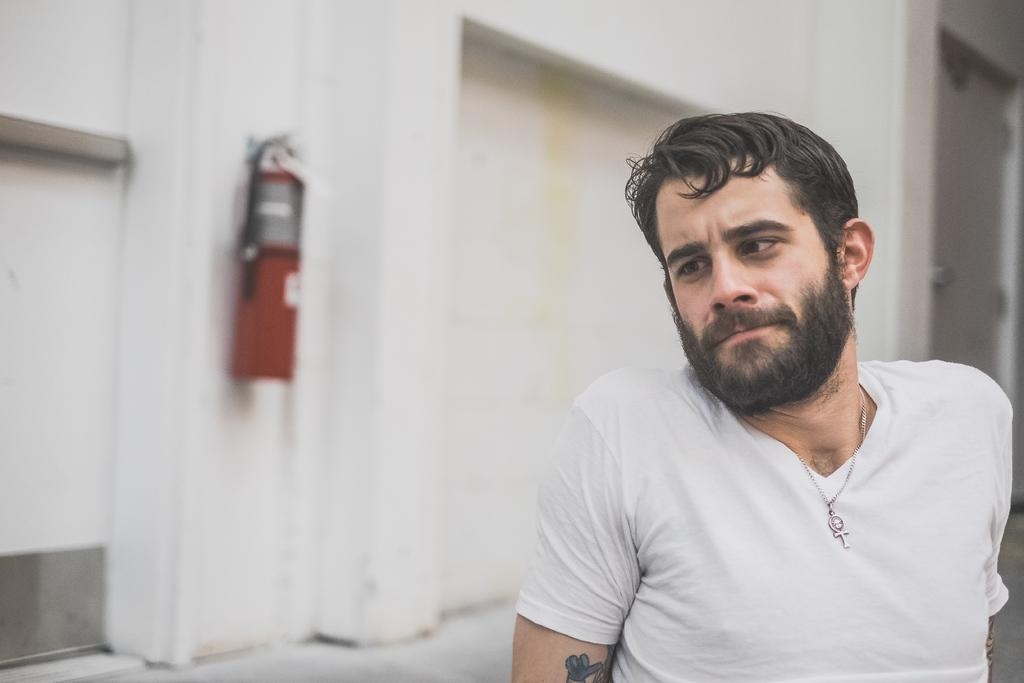Who is present in the image? There is a man in the image. What distinguishing feature does the man have? The man has a tattoo. What can be seen in the background of the image? There is a door, a wall, and a fire extinguisher in the background of the image. What type of border is depicted in the image? There is no border depicted in the image; it features a man with a tattoo and a background with a door, wall, and fire extinguisher. What type of war is being fought in the image? There is no war depicted in the image; it is a picture of a man with a tattoo and a background with a door, wall, and fire extinguisher. 